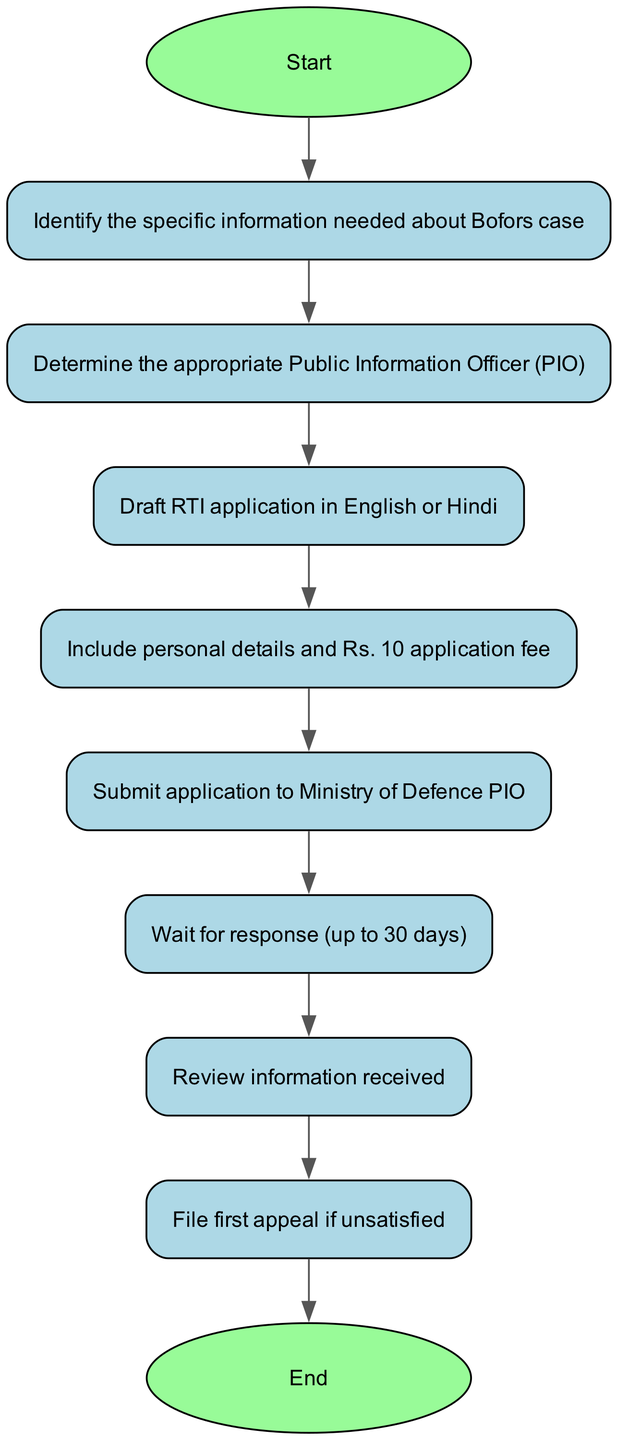What is the first step in the RTI filing process? The diagram starts with the node labeled "Start," which leads to the first action of identifying specific information about the Bofors case.
Answer: Identify the specific information needed about Bofors case How many nodes are in the diagram? By counting all the distinct actions and steps in the diagram, we can see there are 10 nodes, including the start and end points.
Answer: 10 What follows after submitting the RTI application? The sequence of actions in the flow chart indicates that after submitting the application, the next step is to wait for a response.
Answer: Wait for response (up to 30 days) If someone is unsatisfied with the received information, what is the next action? After reviewing the information, the diagram shows that if the recipient is not satisfied, the next action is to file the first appeal.
Answer: File first appeal if unsatisfied What is included in the RTI application according to the diagram? The diagram explicitly states that the application must include personal details and the Rs. 10 application fee, which is a required component of the RTI application process.
Answer: Include personal details and Rs. 10 application fee Which node is directly connected to the "Determine the appropriate Public Information Officer (PIO)" node? Following the connections in the diagram, the node that comes directly after determining the PIO is the drafting of the RTI application.
Answer: Draft RTI application in English or Hindi What is the last action in the process? The final node in the flow chart is labeled "End," which indicates the completion of the process after all previous steps have been followed.
Answer: End 